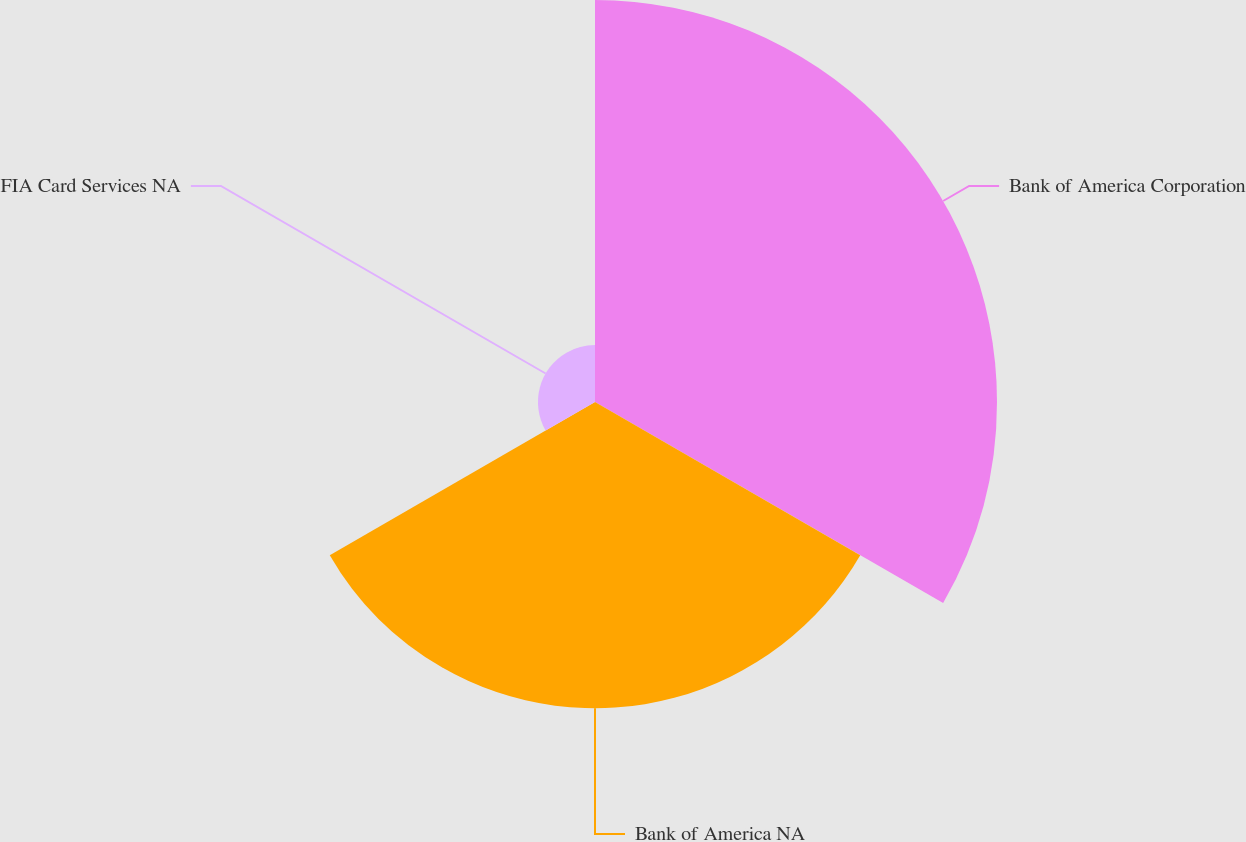<chart> <loc_0><loc_0><loc_500><loc_500><pie_chart><fcel>Bank of America Corporation<fcel>Bank of America NA<fcel>FIA Card Services NA<nl><fcel>52.53%<fcel>40.02%<fcel>7.45%<nl></chart> 